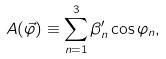Convert formula to latex. <formula><loc_0><loc_0><loc_500><loc_500>A ( \vec { \varphi } ) \equiv \sum _ { n = 1 } ^ { 3 } \beta _ { n } ^ { \prime } \cos \varphi _ { n } ,</formula> 